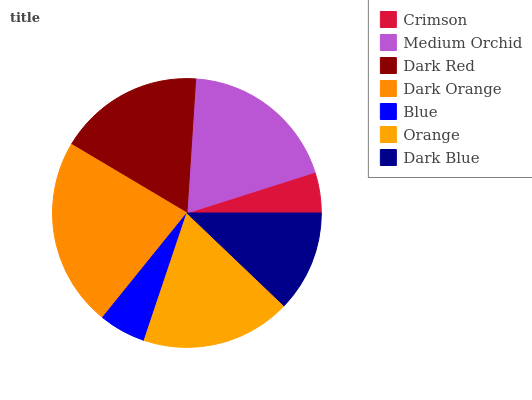Is Crimson the minimum?
Answer yes or no. Yes. Is Dark Orange the maximum?
Answer yes or no. Yes. Is Medium Orchid the minimum?
Answer yes or no. No. Is Medium Orchid the maximum?
Answer yes or no. No. Is Medium Orchid greater than Crimson?
Answer yes or no. Yes. Is Crimson less than Medium Orchid?
Answer yes or no. Yes. Is Crimson greater than Medium Orchid?
Answer yes or no. No. Is Medium Orchid less than Crimson?
Answer yes or no. No. Is Dark Red the high median?
Answer yes or no. Yes. Is Dark Red the low median?
Answer yes or no. Yes. Is Orange the high median?
Answer yes or no. No. Is Orange the low median?
Answer yes or no. No. 